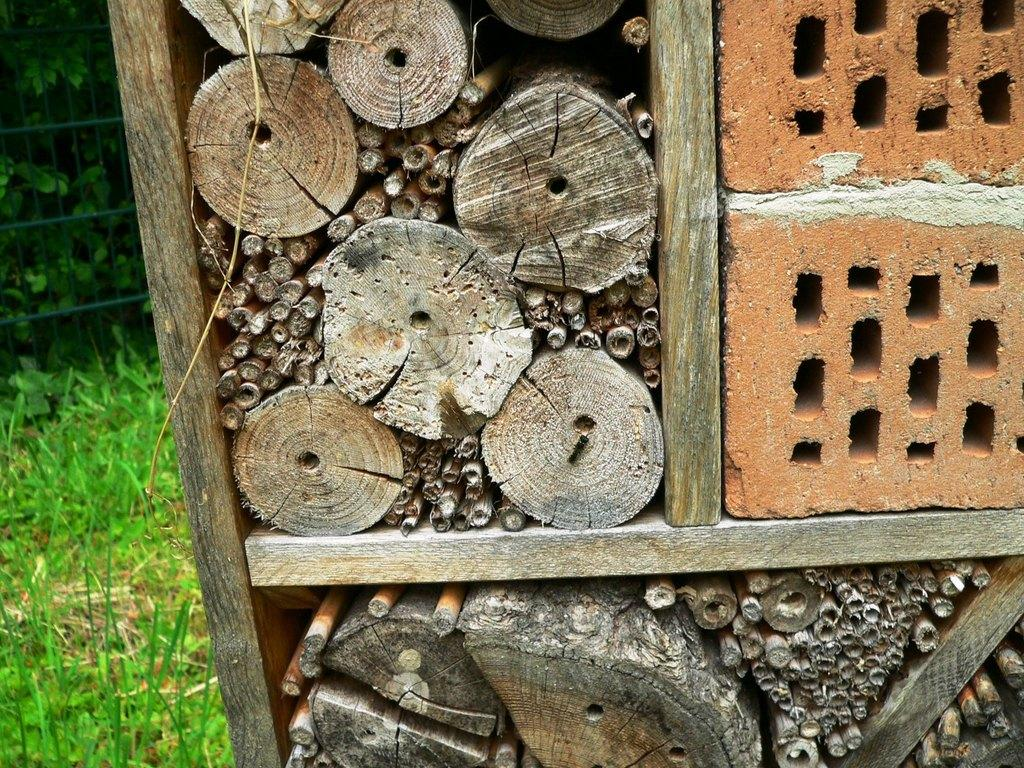What type of natural materials are present in the image? There are wood logs and stones in the image. How are the wood logs and stones arranged in the image? The wood logs and stones are in a rack. What can be seen in the background of the image? There are trees and a fence in the background of the image. Can you see any clover growing near the wood logs and stones? There is no clover visible in the image. Are there any servants attending to the wood logs and stones in the image? There are no servants present in the image. 